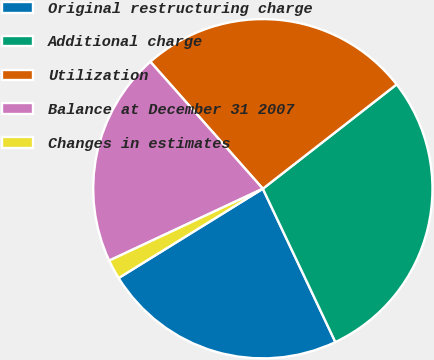Convert chart to OTSL. <chart><loc_0><loc_0><loc_500><loc_500><pie_chart><fcel>Original restructuring charge<fcel>Additional charge<fcel>Utilization<fcel>Balance at December 31 2007<fcel>Changes in estimates<nl><fcel>23.21%<fcel>28.51%<fcel>26.0%<fcel>20.43%<fcel>1.86%<nl></chart> 